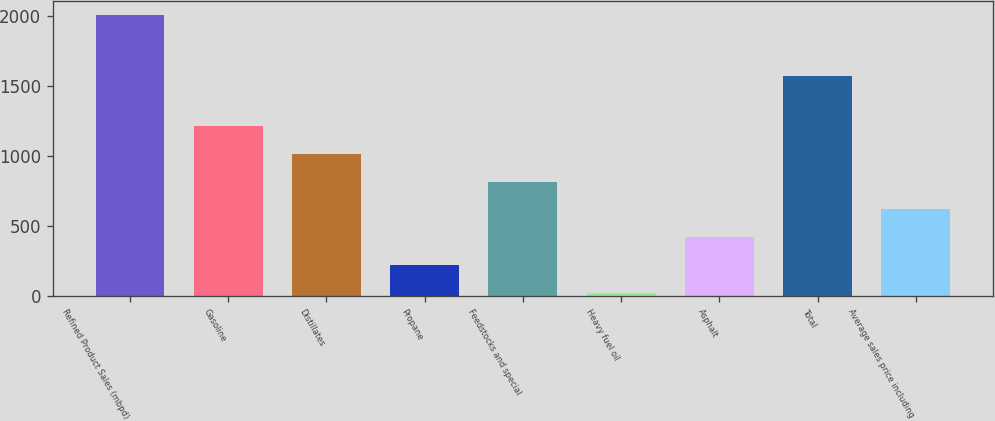Convert chart. <chart><loc_0><loc_0><loc_500><loc_500><bar_chart><fcel>Refined Product Sales (mbpd)<fcel>Gasoline<fcel>Distillates<fcel>Propane<fcel>Feedstocks and special<fcel>Heavy fuel oil<fcel>Asphalt<fcel>Total<fcel>Average sales price including<nl><fcel>2010<fcel>1215.2<fcel>1016.5<fcel>221.7<fcel>817.8<fcel>23<fcel>420.4<fcel>1573<fcel>619.1<nl></chart> 